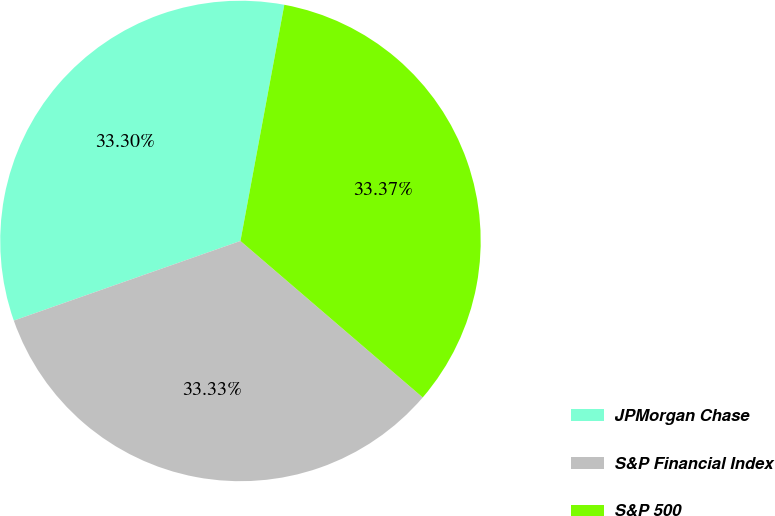Convert chart. <chart><loc_0><loc_0><loc_500><loc_500><pie_chart><fcel>JPMorgan Chase<fcel>S&P Financial Index<fcel>S&P 500<nl><fcel>33.3%<fcel>33.33%<fcel>33.37%<nl></chart> 